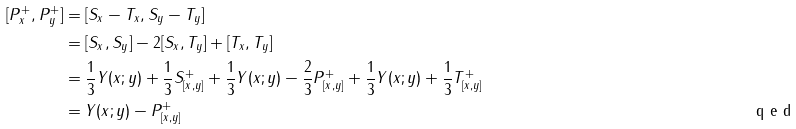Convert formula to latex. <formula><loc_0><loc_0><loc_500><loc_500>[ P ^ { + } _ { x } , P ^ { + } _ { y } ] & = [ S _ { x } - T _ { x } , S _ { y } - T _ { y } ] \\ & = [ S _ { x } , S _ { y } ] - 2 [ S _ { x } , T _ { y } ] + [ T _ { x } , T _ { y } ] \\ & = \frac { 1 } { 3 } Y ( x ; y ) + \frac { 1 } { 3 } S ^ { + } _ { [ x , y ] } + \frac { 1 } { 3 } Y ( x ; y ) - \frac { 2 } { 3 } P ^ { + } _ { [ x , y ] } + \frac { 1 } { 3 } Y ( x ; y ) + \frac { 1 } { 3 } T ^ { + } _ { [ x , y ] } \\ & = Y ( x ; y ) - P ^ { + } _ { [ x , y ] } \tag* { \ q e d }</formula> 